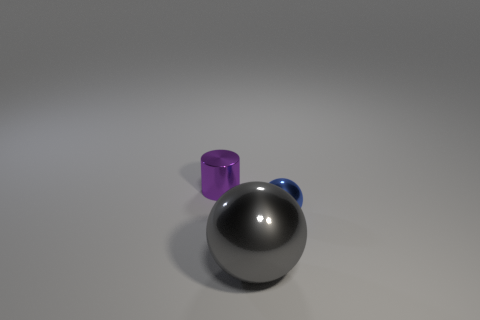Is there any other thing that has the same size as the gray ball?
Make the answer very short. No. What number of objects have the same material as the cylinder?
Ensure brevity in your answer.  2. There is a small object that is to the right of the metal cylinder; how many gray metal objects are behind it?
Offer a very short reply. 0. What number of tiny purple shiny cylinders are there?
Ensure brevity in your answer.  1. Is the material of the gray sphere the same as the small object that is left of the big shiny sphere?
Make the answer very short. Yes. How big is the purple shiny thing?
Provide a succinct answer. Small. Does the metallic thing that is to the right of the large ball have the same size as the thing that is behind the blue shiny thing?
Your response must be concise. Yes. The thing to the right of the big ball is what color?
Offer a terse response. Blue. Is the number of things behind the tiny metallic cylinder less than the number of tiny yellow spheres?
Keep it short and to the point. No. Do the blue sphere and the small cylinder have the same material?
Make the answer very short. Yes. 